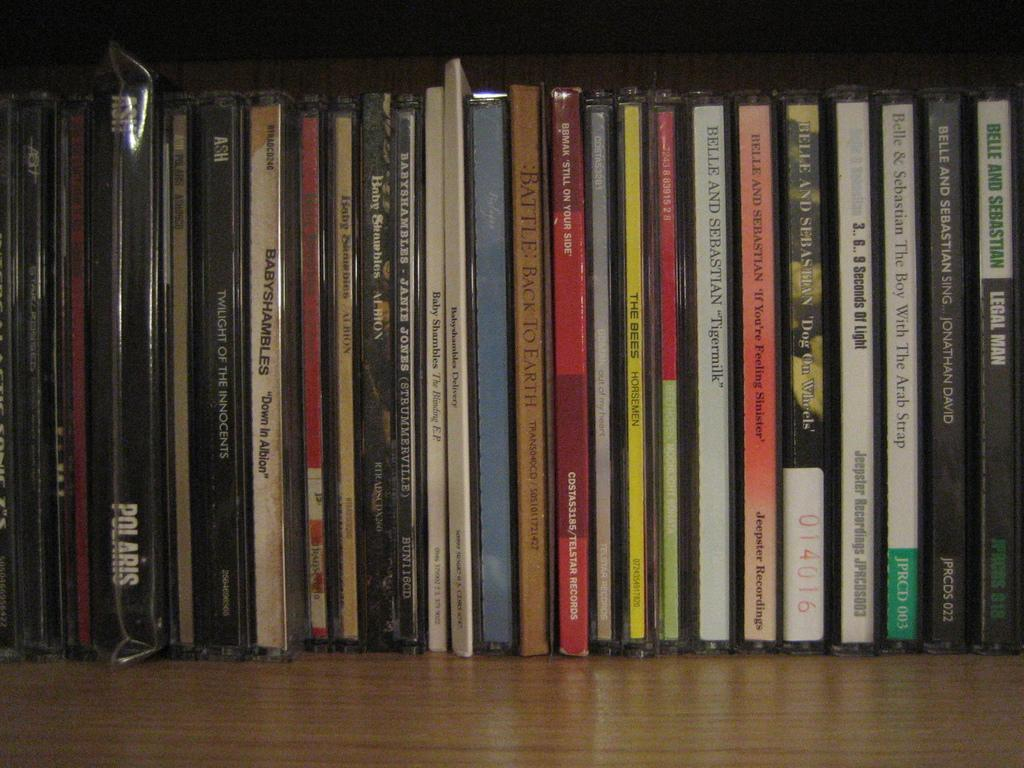What type of objects are visible in the image? There is a bunch of compact discs in the image. Can you describe the appearance of the compact discs? The compact discs are round and shiny, with a central hole and a label on one side. How are the compact discs arranged in the image? The compact discs are stacked or arranged in a pile or group. What type of pie is being served on the compact discs in the image? There is no pie present in the image; it features a bunch of compact discs. How many stitches are visible on the compact discs in the image? Compact discs do not have stitches, as they are made of plastic and have a smooth surface. 